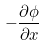Convert formula to latex. <formula><loc_0><loc_0><loc_500><loc_500>- \frac { \partial \phi } { \partial x }</formula> 